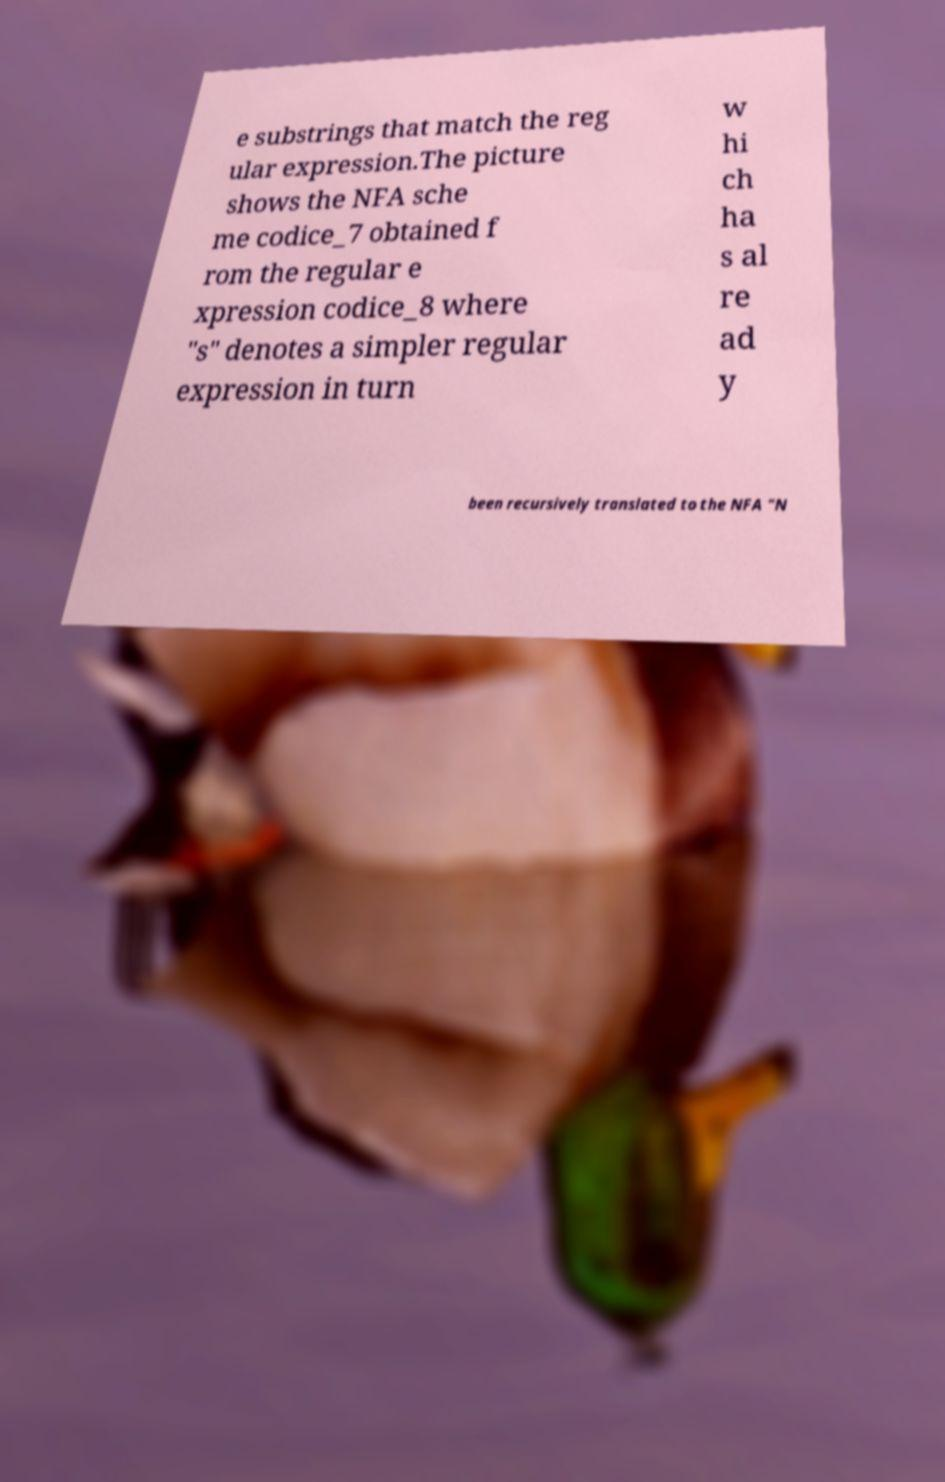Can you accurately transcribe the text from the provided image for me? e substrings that match the reg ular expression.The picture shows the NFA sche me codice_7 obtained f rom the regular e xpression codice_8 where "s" denotes a simpler regular expression in turn w hi ch ha s al re ad y been recursively translated to the NFA "N 